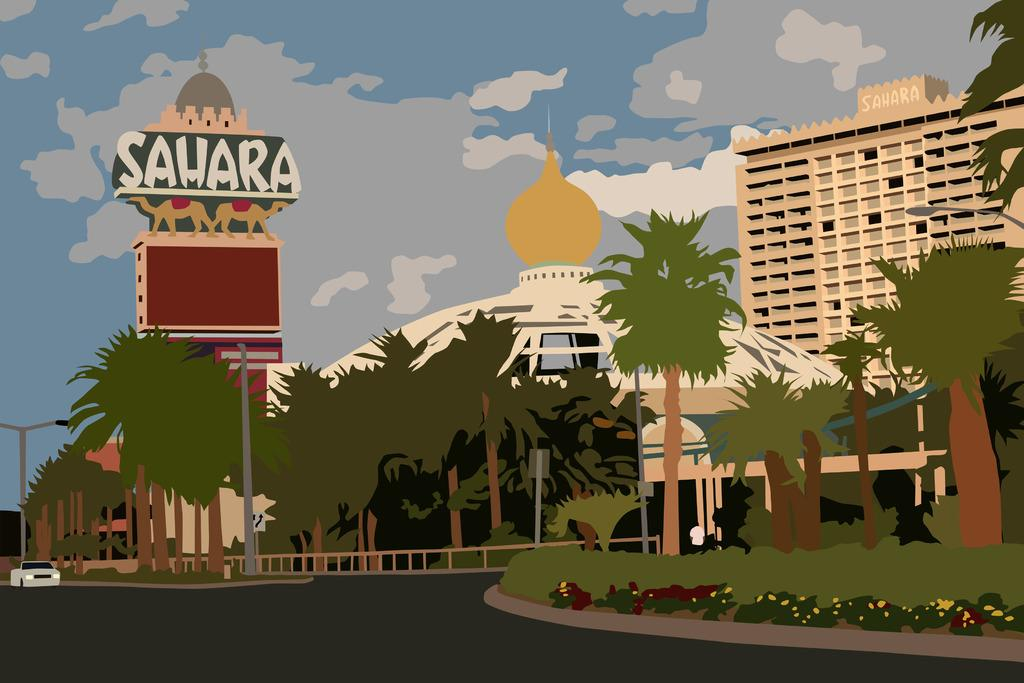What is a primary element visible in the image? The sky is a primary element visible in the image. What can be seen in the sky? Clouds are visible in the sky. What type of structures are present in the image? There are buildings in the image. What type of vegetation is present in the image? Trees and plants are present in the image. What type of man-made objects are present in the image? Poles, fences, and a road are present in the image. What type of vehicle is present in the image? There is a car in the image. What type of coat is the tree wearing in the image? Trees do not wear coats; they are plants with bark and leaves. 